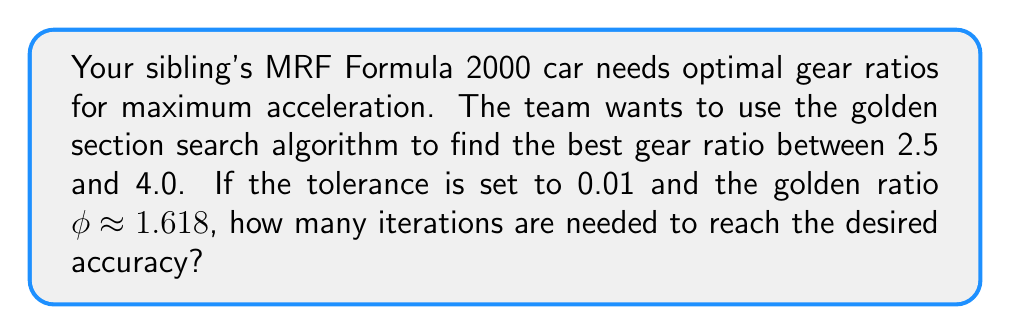Could you help me with this problem? Let's approach this step-by-step:

1) The golden section search algorithm uses the golden ratio φ ≈ 1.618 to narrow down the search interval.

2) The reduction factor per iteration is:
   $r = \frac{\phi - 1}{\phi} \approx 0.618$

3) The initial interval is [2.5, 4.0], so the initial range is:
   $4.0 - 2.5 = 1.5$

4) We need to find n such that:
   $1.5 \cdot r^n \leq 0.01$

5) Taking logarithms of both sides:
   $\log(1.5) + n \log(r) \leq \log(0.01)$

6) Solving for n:
   $n \geq \frac{\log(0.01) - \log(1.5)}{\log(r)}$

7) Substituting the values:
   $n \geq \frac{\log(0.01) - \log(1.5)}{\log(0.618)} \approx 11.67$

8) Since n must be an integer, we round up to the next whole number.
Answer: 12 iterations 